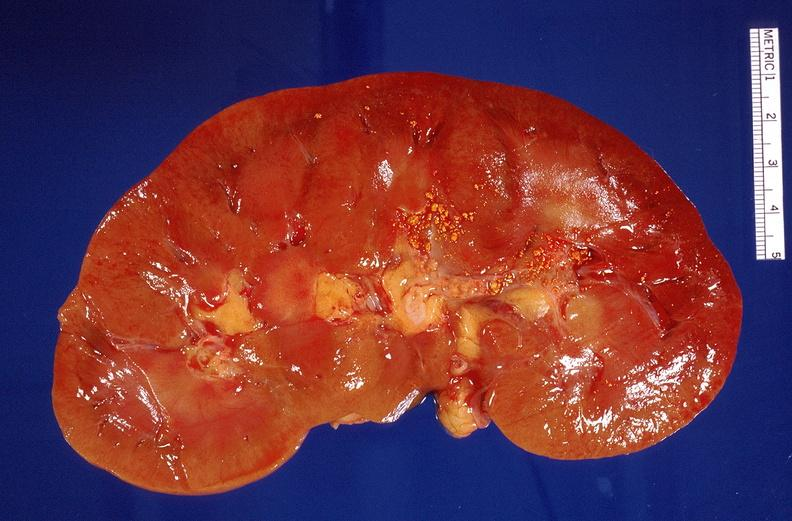where is this?
Answer the question using a single word or phrase. Urinary 